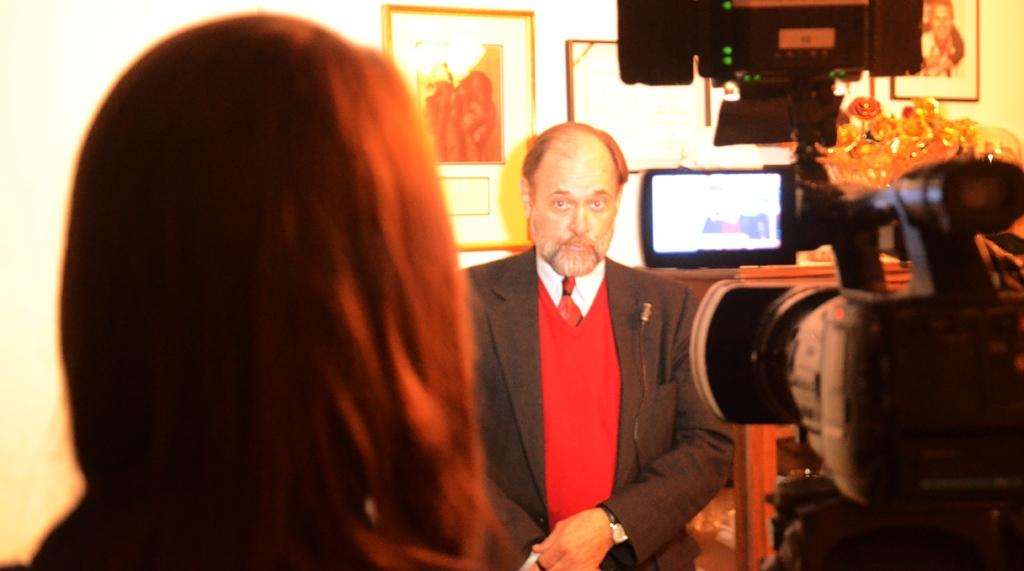What is the person in the image doing? The person in the image is holding a camera. Can you describe the setting of the image? There is another person in the background of the image, and there are frames attached to the wall and a television present. What objects can be seen on the cupboard in the background? There are objects on a cupboard in the background, but their specific nature is not mentioned in the facts. How many people are visible in the image? There are two people visible in the image. What type of chalk is being used to draw on the hospital floor in the image? There is no chalk or hospital present in the image; it features a person holding a camera and a background with frames, a television, and objects on a cupboard. 